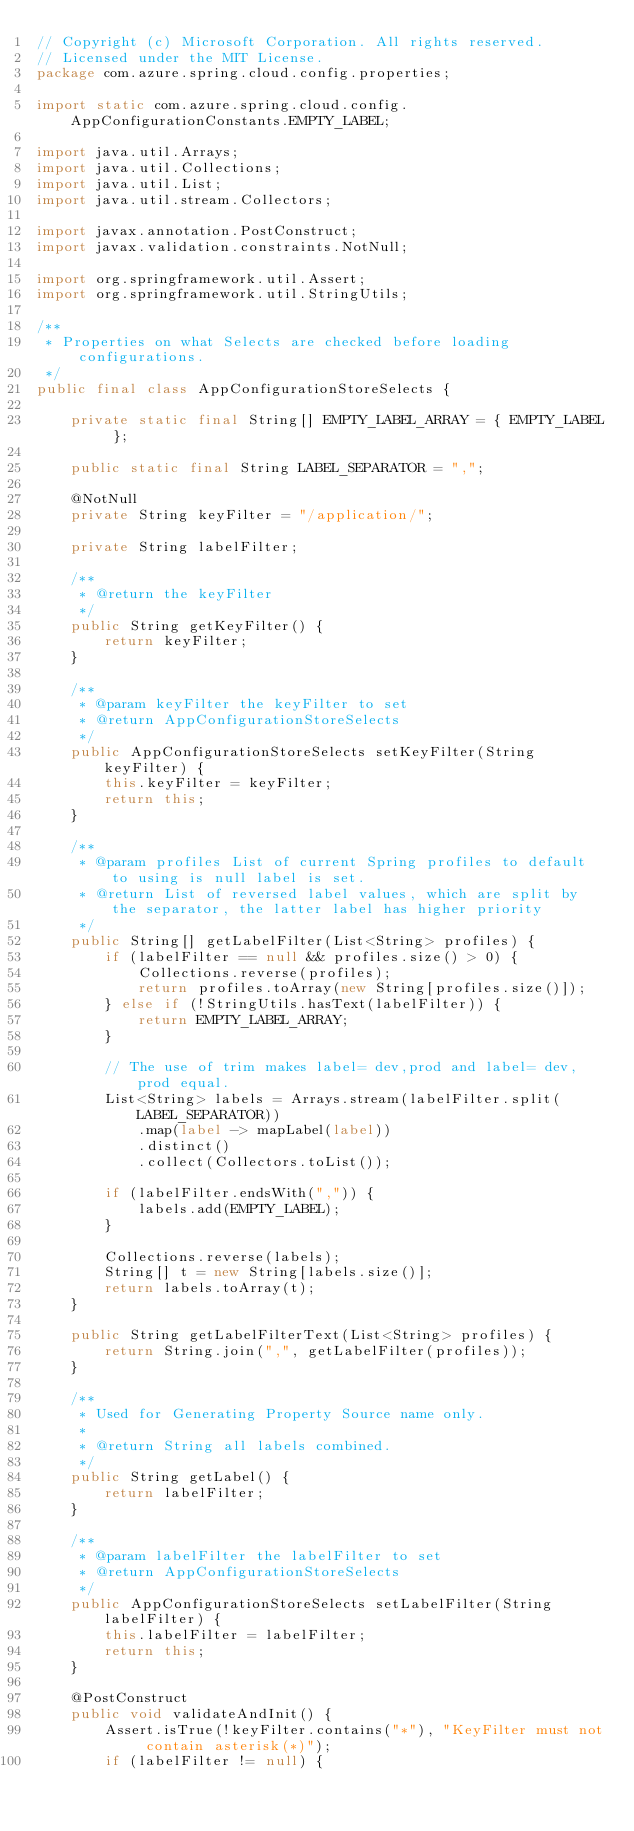Convert code to text. <code><loc_0><loc_0><loc_500><loc_500><_Java_>// Copyright (c) Microsoft Corporation. All rights reserved.
// Licensed under the MIT License.
package com.azure.spring.cloud.config.properties;

import static com.azure.spring.cloud.config.AppConfigurationConstants.EMPTY_LABEL;

import java.util.Arrays;
import java.util.Collections;
import java.util.List;
import java.util.stream.Collectors;

import javax.annotation.PostConstruct;
import javax.validation.constraints.NotNull;

import org.springframework.util.Assert;
import org.springframework.util.StringUtils;

/**
 * Properties on what Selects are checked before loading configurations.
 */
public final class AppConfigurationStoreSelects {

    private static final String[] EMPTY_LABEL_ARRAY = { EMPTY_LABEL };

    public static final String LABEL_SEPARATOR = ",";

    @NotNull
    private String keyFilter = "/application/";

    private String labelFilter;

    /**
     * @return the keyFilter
     */
    public String getKeyFilter() {
        return keyFilter;
    }

    /**
     * @param keyFilter the keyFilter to set
     * @return AppConfigurationStoreSelects
     */
    public AppConfigurationStoreSelects setKeyFilter(String keyFilter) {
        this.keyFilter = keyFilter;
        return this;
    }

    /**
     * @param profiles List of current Spring profiles to default to using is null label is set.
     * @return List of reversed label values, which are split by the separator, the latter label has higher priority
     */
    public String[] getLabelFilter(List<String> profiles) {
        if (labelFilter == null && profiles.size() > 0) {
            Collections.reverse(profiles);
            return profiles.toArray(new String[profiles.size()]);
        } else if (!StringUtils.hasText(labelFilter)) {
            return EMPTY_LABEL_ARRAY;
        }

        // The use of trim makes label= dev,prod and label= dev, prod equal.
        List<String> labels = Arrays.stream(labelFilter.split(LABEL_SEPARATOR))
            .map(label -> mapLabel(label))
            .distinct()
            .collect(Collectors.toList());

        if (labelFilter.endsWith(",")) {
            labels.add(EMPTY_LABEL);
        }

        Collections.reverse(labels);
        String[] t = new String[labels.size()];
        return labels.toArray(t);
    }

    public String getLabelFilterText(List<String> profiles) {
        return String.join(",", getLabelFilter(profiles));
    }

    /**
     * Used for Generating Property Source name only.
     * 
     * @return String all labels combined.
     */
    public String getLabel() {
        return labelFilter;
    }

    /**
     * @param labelFilter the labelFilter to set
     * @return AppConfigurationStoreSelects
     */
    public AppConfigurationStoreSelects setLabelFilter(String labelFilter) {
        this.labelFilter = labelFilter;
        return this;
    }

    @PostConstruct
    public void validateAndInit() {
        Assert.isTrue(!keyFilter.contains("*"), "KeyFilter must not contain asterisk(*)");
        if (labelFilter != null) {</code> 